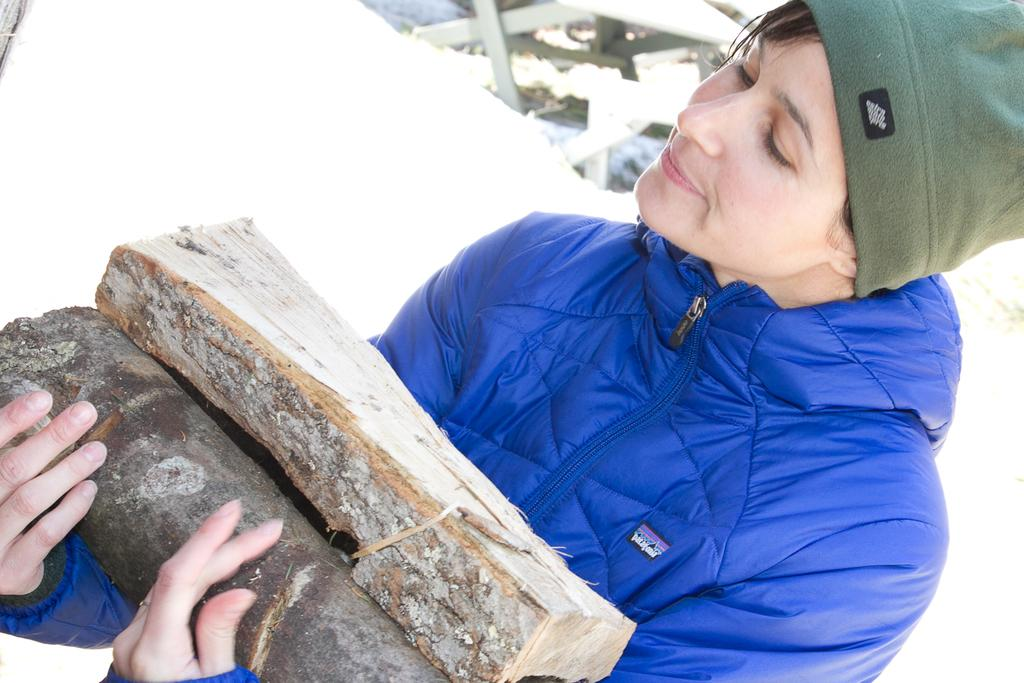What is the main subject of the image? There is a person in the image. What is the person doing in the image? The person is standing in the image. What is the person holding in the image? The person is holding stems in the image. What type of poison is the person using in the image? There is no poison present in the image; the person is holding stems. What scientific theory is the person discussing in the image? There is no indication in the image that the person is discussing any scientific theory. 